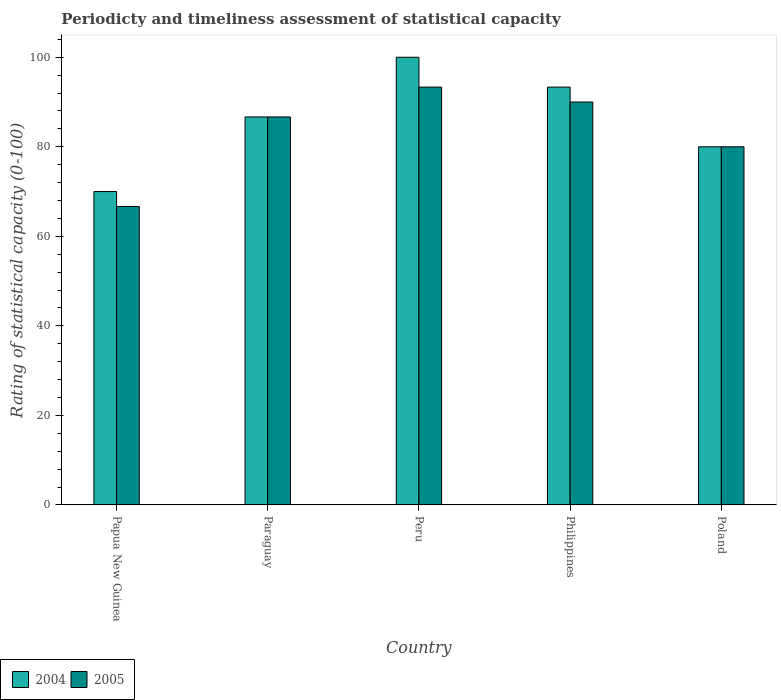How many groups of bars are there?
Offer a terse response. 5. What is the label of the 2nd group of bars from the left?
Offer a terse response. Paraguay. What is the rating of statistical capacity in 2004 in Peru?
Keep it short and to the point. 100. Across all countries, what is the maximum rating of statistical capacity in 2005?
Offer a terse response. 93.33. Across all countries, what is the minimum rating of statistical capacity in 2004?
Your answer should be very brief. 70. In which country was the rating of statistical capacity in 2005 maximum?
Provide a short and direct response. Peru. In which country was the rating of statistical capacity in 2005 minimum?
Offer a very short reply. Papua New Guinea. What is the total rating of statistical capacity in 2005 in the graph?
Your answer should be compact. 416.67. What is the difference between the rating of statistical capacity in 2004 in Paraguay and that in Poland?
Give a very brief answer. 6.67. What is the difference between the rating of statistical capacity in 2005 in Papua New Guinea and the rating of statistical capacity in 2004 in Peru?
Give a very brief answer. -33.33. What is the average rating of statistical capacity in 2004 per country?
Make the answer very short. 86. What is the difference between the rating of statistical capacity of/in 2004 and rating of statistical capacity of/in 2005 in Peru?
Give a very brief answer. 6.67. What is the ratio of the rating of statistical capacity in 2005 in Papua New Guinea to that in Peru?
Ensure brevity in your answer.  0.71. Is the rating of statistical capacity in 2005 in Peru less than that in Philippines?
Make the answer very short. No. What is the difference between the highest and the second highest rating of statistical capacity in 2005?
Provide a succinct answer. -3.33. What is the difference between the highest and the lowest rating of statistical capacity in 2005?
Give a very brief answer. 26.67. Is the sum of the rating of statistical capacity in 2005 in Peru and Philippines greater than the maximum rating of statistical capacity in 2004 across all countries?
Your answer should be very brief. Yes. What does the 1st bar from the right in Papua New Guinea represents?
Your answer should be very brief. 2005. Are all the bars in the graph horizontal?
Your response must be concise. No. How many countries are there in the graph?
Provide a short and direct response. 5. How many legend labels are there?
Provide a succinct answer. 2. How are the legend labels stacked?
Your answer should be compact. Horizontal. What is the title of the graph?
Ensure brevity in your answer.  Periodicty and timeliness assessment of statistical capacity. What is the label or title of the X-axis?
Make the answer very short. Country. What is the label or title of the Y-axis?
Give a very brief answer. Rating of statistical capacity (0-100). What is the Rating of statistical capacity (0-100) in 2004 in Papua New Guinea?
Provide a succinct answer. 70. What is the Rating of statistical capacity (0-100) in 2005 in Papua New Guinea?
Provide a succinct answer. 66.67. What is the Rating of statistical capacity (0-100) in 2004 in Paraguay?
Your answer should be compact. 86.67. What is the Rating of statistical capacity (0-100) in 2005 in Paraguay?
Offer a terse response. 86.67. What is the Rating of statistical capacity (0-100) in 2005 in Peru?
Your answer should be very brief. 93.33. What is the Rating of statistical capacity (0-100) in 2004 in Philippines?
Your answer should be very brief. 93.33. What is the Rating of statistical capacity (0-100) in 2005 in Philippines?
Keep it short and to the point. 90. What is the Rating of statistical capacity (0-100) in 2004 in Poland?
Offer a terse response. 80. What is the Rating of statistical capacity (0-100) in 2005 in Poland?
Provide a short and direct response. 80. Across all countries, what is the maximum Rating of statistical capacity (0-100) of 2004?
Give a very brief answer. 100. Across all countries, what is the maximum Rating of statistical capacity (0-100) of 2005?
Give a very brief answer. 93.33. Across all countries, what is the minimum Rating of statistical capacity (0-100) of 2005?
Keep it short and to the point. 66.67. What is the total Rating of statistical capacity (0-100) of 2004 in the graph?
Offer a very short reply. 430. What is the total Rating of statistical capacity (0-100) in 2005 in the graph?
Your answer should be compact. 416.67. What is the difference between the Rating of statistical capacity (0-100) of 2004 in Papua New Guinea and that in Paraguay?
Give a very brief answer. -16.67. What is the difference between the Rating of statistical capacity (0-100) of 2005 in Papua New Guinea and that in Paraguay?
Your answer should be compact. -20. What is the difference between the Rating of statistical capacity (0-100) of 2005 in Papua New Guinea and that in Peru?
Make the answer very short. -26.67. What is the difference between the Rating of statistical capacity (0-100) of 2004 in Papua New Guinea and that in Philippines?
Make the answer very short. -23.33. What is the difference between the Rating of statistical capacity (0-100) in 2005 in Papua New Guinea and that in Philippines?
Provide a succinct answer. -23.33. What is the difference between the Rating of statistical capacity (0-100) of 2005 in Papua New Guinea and that in Poland?
Provide a succinct answer. -13.33. What is the difference between the Rating of statistical capacity (0-100) in 2004 in Paraguay and that in Peru?
Make the answer very short. -13.33. What is the difference between the Rating of statistical capacity (0-100) in 2005 in Paraguay and that in Peru?
Your answer should be compact. -6.67. What is the difference between the Rating of statistical capacity (0-100) of 2004 in Paraguay and that in Philippines?
Give a very brief answer. -6.67. What is the difference between the Rating of statistical capacity (0-100) of 2005 in Paraguay and that in Philippines?
Your response must be concise. -3.33. What is the difference between the Rating of statistical capacity (0-100) in 2005 in Paraguay and that in Poland?
Your answer should be compact. 6.67. What is the difference between the Rating of statistical capacity (0-100) in 2004 in Peru and that in Philippines?
Your response must be concise. 6.67. What is the difference between the Rating of statistical capacity (0-100) of 2005 in Peru and that in Poland?
Give a very brief answer. 13.33. What is the difference between the Rating of statistical capacity (0-100) of 2004 in Philippines and that in Poland?
Your answer should be very brief. 13.33. What is the difference between the Rating of statistical capacity (0-100) in 2005 in Philippines and that in Poland?
Your answer should be compact. 10. What is the difference between the Rating of statistical capacity (0-100) in 2004 in Papua New Guinea and the Rating of statistical capacity (0-100) in 2005 in Paraguay?
Your answer should be very brief. -16.67. What is the difference between the Rating of statistical capacity (0-100) of 2004 in Papua New Guinea and the Rating of statistical capacity (0-100) of 2005 in Peru?
Your answer should be compact. -23.33. What is the difference between the Rating of statistical capacity (0-100) of 2004 in Paraguay and the Rating of statistical capacity (0-100) of 2005 in Peru?
Ensure brevity in your answer.  -6.67. What is the difference between the Rating of statistical capacity (0-100) of 2004 in Paraguay and the Rating of statistical capacity (0-100) of 2005 in Poland?
Your answer should be very brief. 6.67. What is the difference between the Rating of statistical capacity (0-100) of 2004 in Peru and the Rating of statistical capacity (0-100) of 2005 in Philippines?
Offer a terse response. 10. What is the difference between the Rating of statistical capacity (0-100) of 2004 in Philippines and the Rating of statistical capacity (0-100) of 2005 in Poland?
Your answer should be very brief. 13.33. What is the average Rating of statistical capacity (0-100) in 2004 per country?
Offer a very short reply. 86. What is the average Rating of statistical capacity (0-100) in 2005 per country?
Ensure brevity in your answer.  83.33. What is the difference between the Rating of statistical capacity (0-100) in 2004 and Rating of statistical capacity (0-100) in 2005 in Paraguay?
Offer a very short reply. 0. What is the difference between the Rating of statistical capacity (0-100) in 2004 and Rating of statistical capacity (0-100) in 2005 in Peru?
Ensure brevity in your answer.  6.67. What is the ratio of the Rating of statistical capacity (0-100) of 2004 in Papua New Guinea to that in Paraguay?
Give a very brief answer. 0.81. What is the ratio of the Rating of statistical capacity (0-100) of 2005 in Papua New Guinea to that in Paraguay?
Ensure brevity in your answer.  0.77. What is the ratio of the Rating of statistical capacity (0-100) of 2004 in Papua New Guinea to that in Peru?
Provide a succinct answer. 0.7. What is the ratio of the Rating of statistical capacity (0-100) in 2005 in Papua New Guinea to that in Peru?
Provide a short and direct response. 0.71. What is the ratio of the Rating of statistical capacity (0-100) in 2005 in Papua New Guinea to that in Philippines?
Your response must be concise. 0.74. What is the ratio of the Rating of statistical capacity (0-100) of 2004 in Paraguay to that in Peru?
Your response must be concise. 0.87. What is the ratio of the Rating of statistical capacity (0-100) of 2005 in Paraguay to that in Peru?
Make the answer very short. 0.93. What is the ratio of the Rating of statistical capacity (0-100) in 2005 in Paraguay to that in Philippines?
Your response must be concise. 0.96. What is the ratio of the Rating of statistical capacity (0-100) in 2005 in Paraguay to that in Poland?
Offer a terse response. 1.08. What is the ratio of the Rating of statistical capacity (0-100) of 2004 in Peru to that in Philippines?
Provide a succinct answer. 1.07. What is the ratio of the Rating of statistical capacity (0-100) in 2005 in Peru to that in Poland?
Offer a terse response. 1.17. What is the difference between the highest and the lowest Rating of statistical capacity (0-100) of 2005?
Your answer should be very brief. 26.67. 